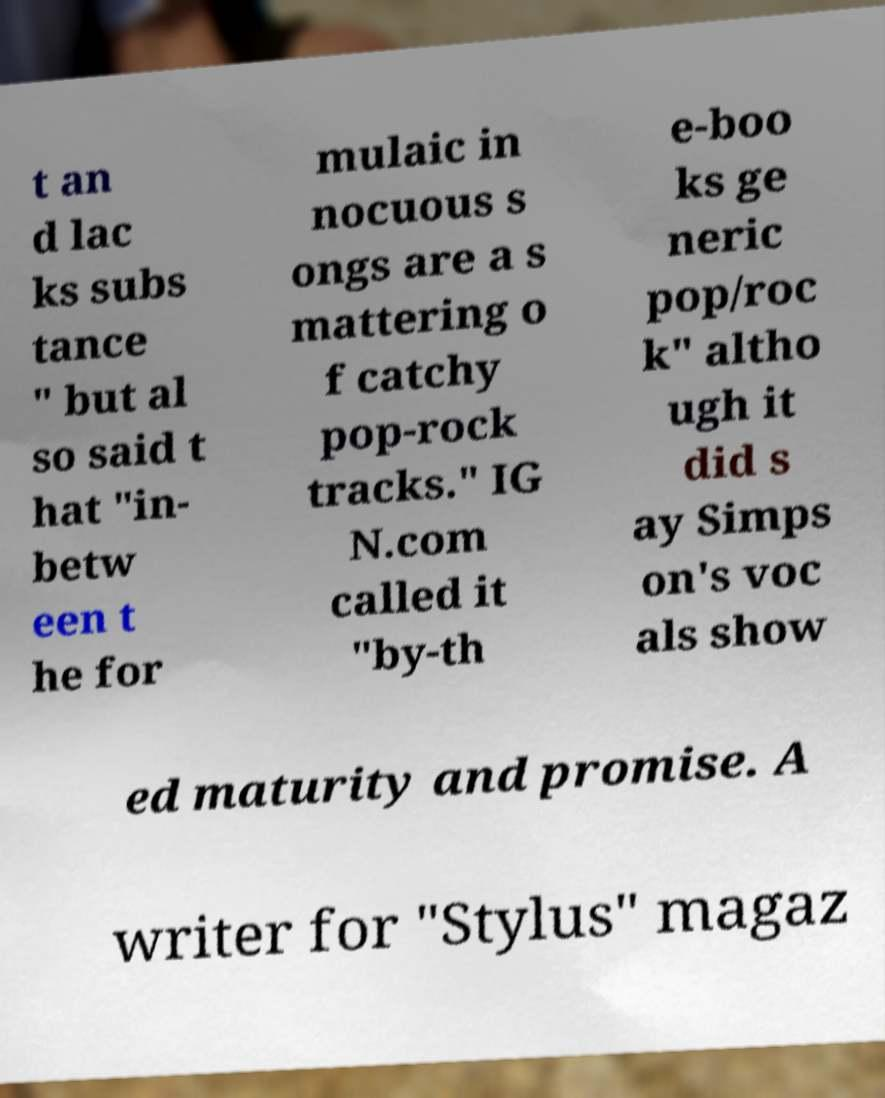Can you read and provide the text displayed in the image?This photo seems to have some interesting text. Can you extract and type it out for me? t an d lac ks subs tance " but al so said t hat "in- betw een t he for mulaic in nocuous s ongs are a s mattering o f catchy pop-rock tracks." IG N.com called it "by-th e-boo ks ge neric pop/roc k" altho ugh it did s ay Simps on's voc als show ed maturity and promise. A writer for "Stylus" magaz 